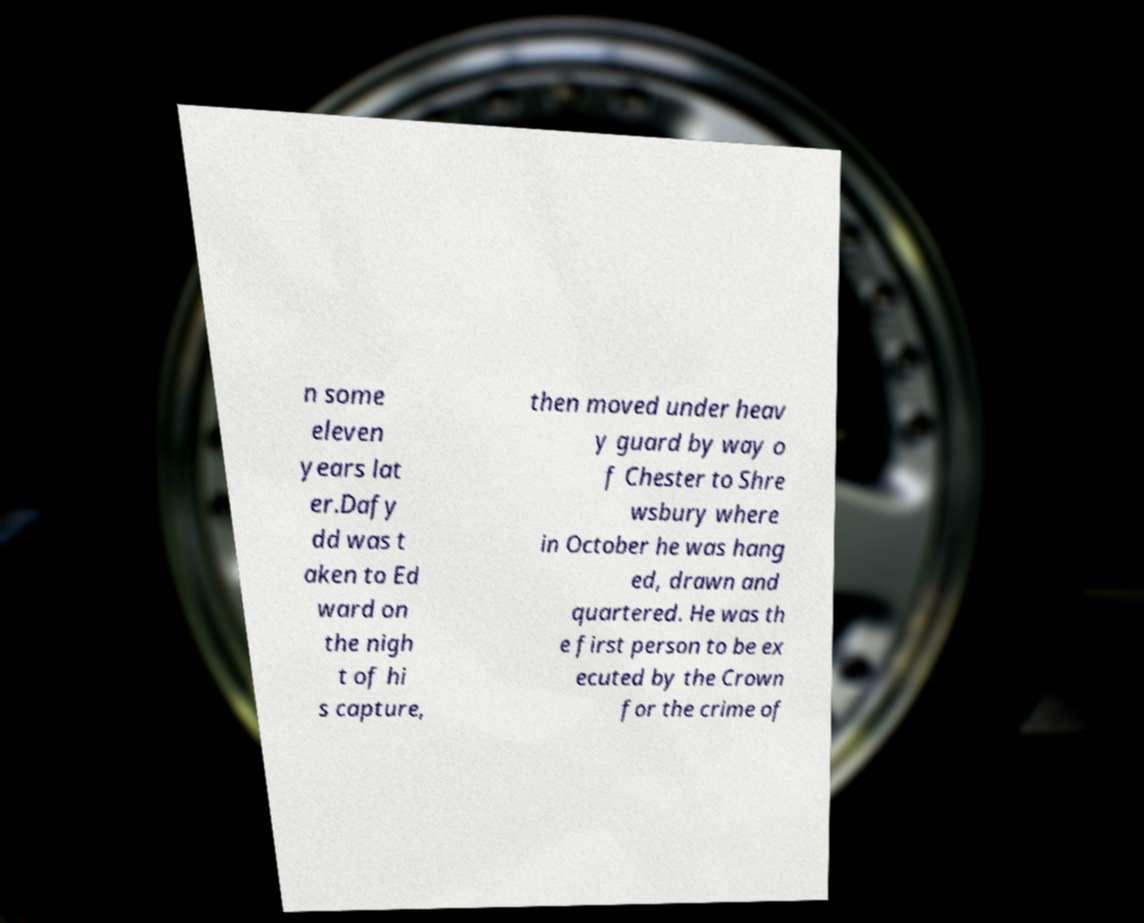Could you assist in decoding the text presented in this image and type it out clearly? n some eleven years lat er.Dafy dd was t aken to Ed ward on the nigh t of hi s capture, then moved under heav y guard by way o f Chester to Shre wsbury where in October he was hang ed, drawn and quartered. He was th e first person to be ex ecuted by the Crown for the crime of 